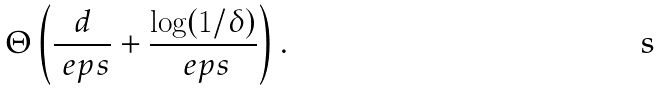<formula> <loc_0><loc_0><loc_500><loc_500>\Theta \left ( \frac { d } { \ e p s } + \frac { \log ( 1 / \delta ) } { \ e p s } \right ) .</formula> 